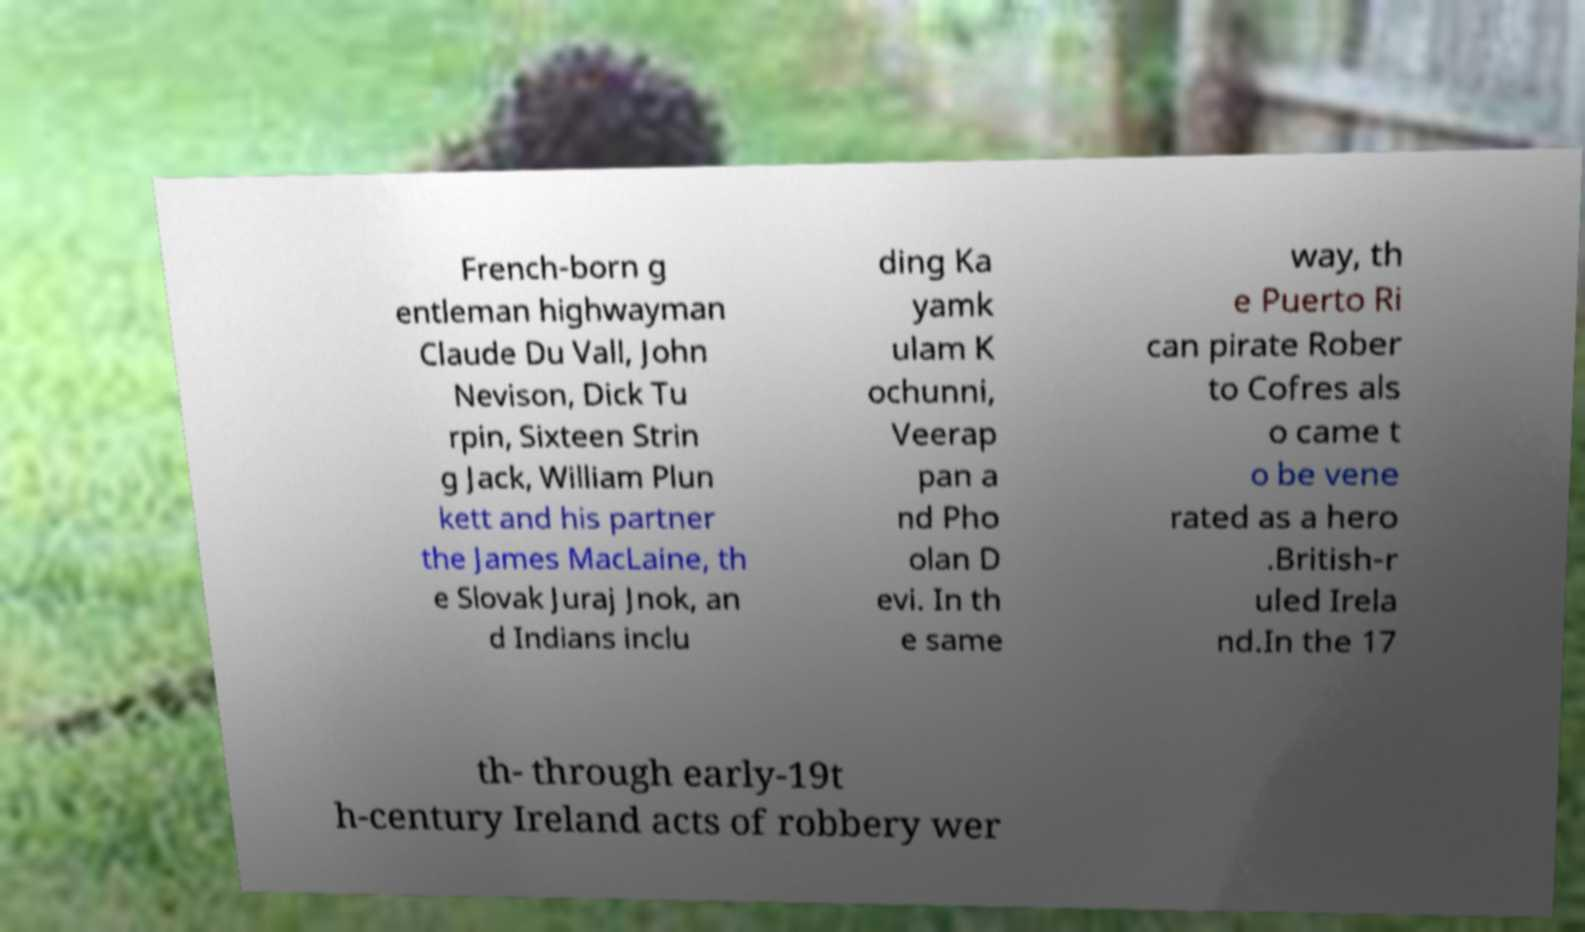Could you extract and type out the text from this image? French-born g entleman highwayman Claude Du Vall, John Nevison, Dick Tu rpin, Sixteen Strin g Jack, William Plun kett and his partner the James MacLaine, th e Slovak Juraj Jnok, an d Indians inclu ding Ka yamk ulam K ochunni, Veerap pan a nd Pho olan D evi. In th e same way, th e Puerto Ri can pirate Rober to Cofres als o came t o be vene rated as a hero .British-r uled Irela nd.In the 17 th- through early-19t h-century Ireland acts of robbery wer 